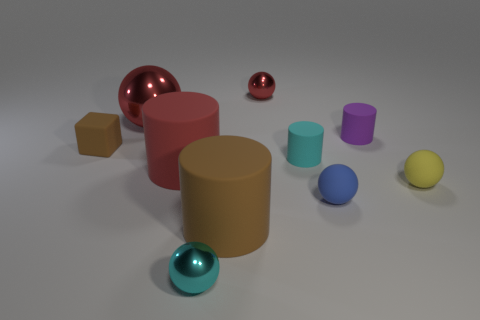Subtract all small purple cylinders. How many cylinders are left? 3 Subtract 1 blue balls. How many objects are left? 9 Subtract all cubes. How many objects are left? 9 Subtract 1 blocks. How many blocks are left? 0 Subtract all gray cubes. Subtract all gray cylinders. How many cubes are left? 1 Subtract all blue cylinders. How many cyan spheres are left? 1 Subtract all tiny cyan cylinders. Subtract all purple cylinders. How many objects are left? 8 Add 6 brown rubber cylinders. How many brown rubber cylinders are left? 7 Add 5 small purple shiny cubes. How many small purple shiny cubes exist? 5 Subtract all red cylinders. How many cylinders are left? 3 